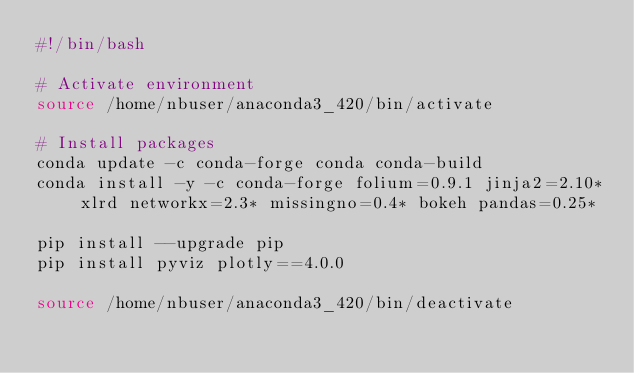Convert code to text. <code><loc_0><loc_0><loc_500><loc_500><_Bash_>#!/bin/bash

# Activate environment
source /home/nbuser/anaconda3_420/bin/activate

# Install packages
conda update -c conda-forge conda conda-build
conda install -y -c conda-forge folium=0.9.1 jinja2=2.10* xlrd networkx=2.3* missingno=0.4* bokeh pandas=0.25*

pip install --upgrade pip
pip install pyviz plotly==4.0.0

source /home/nbuser/anaconda3_420/bin/deactivate
</code> 